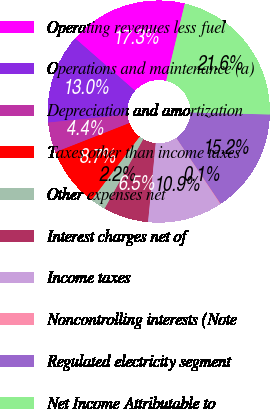<chart> <loc_0><loc_0><loc_500><loc_500><pie_chart><fcel>Operating revenues less fuel<fcel>Operations and maintenance (a)<fcel>Depreciation and amortization<fcel>Taxes other than income taxes<fcel>Other expenses net<fcel>Interest charges net of<fcel>Income taxes<fcel>Noncontrolling interests (Note<fcel>Regulated electricity segment<fcel>Net Income Attributable to<nl><fcel>17.33%<fcel>13.02%<fcel>4.39%<fcel>8.71%<fcel>2.23%<fcel>6.55%<fcel>10.86%<fcel>0.08%<fcel>15.18%<fcel>21.65%<nl></chart> 